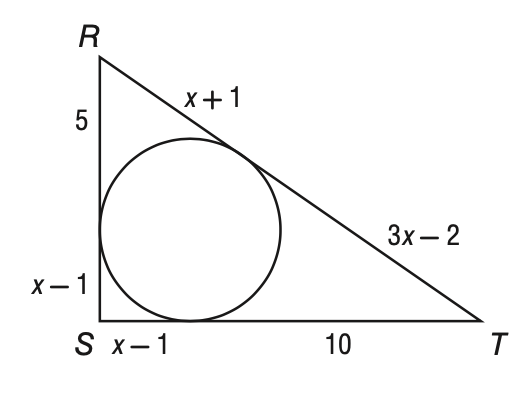Answer the mathemtical geometry problem and directly provide the correct option letter.
Question: Triangle R S T is circumscribed about the circle below. What is the perimeter of the triangle?
Choices: A: 33 B: 36 C: 37 D: 40 B 